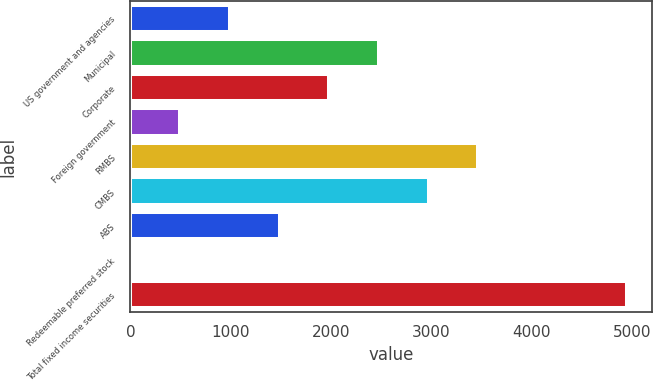<chart> <loc_0><loc_0><loc_500><loc_500><bar_chart><fcel>US government and agencies<fcel>Municipal<fcel>Corporate<fcel>Foreign government<fcel>RMBS<fcel>CMBS<fcel>ABS<fcel>Redeemable preferred stock<fcel>Total fixed income securities<nl><fcel>991.6<fcel>2477.5<fcel>1982.2<fcel>496.3<fcel>3468.1<fcel>2972.8<fcel>1486.9<fcel>1<fcel>4954<nl></chart> 